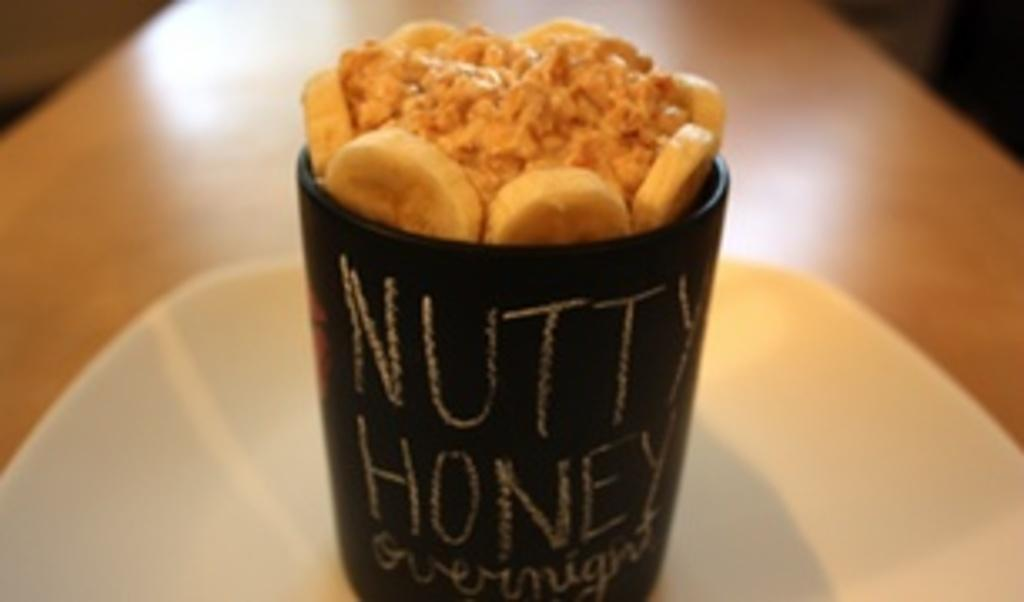What type of food item is in the cup in the image? There is a food item in a cup in the image, but the specific type is not mentioned. What else can be seen on the table in the image? There is a plate on the table in the image. What is written on the cup? There is writing on the cup in the image. What type of wool is used to make the popcorn in the image? There is no popcorn or wool present in the image. 